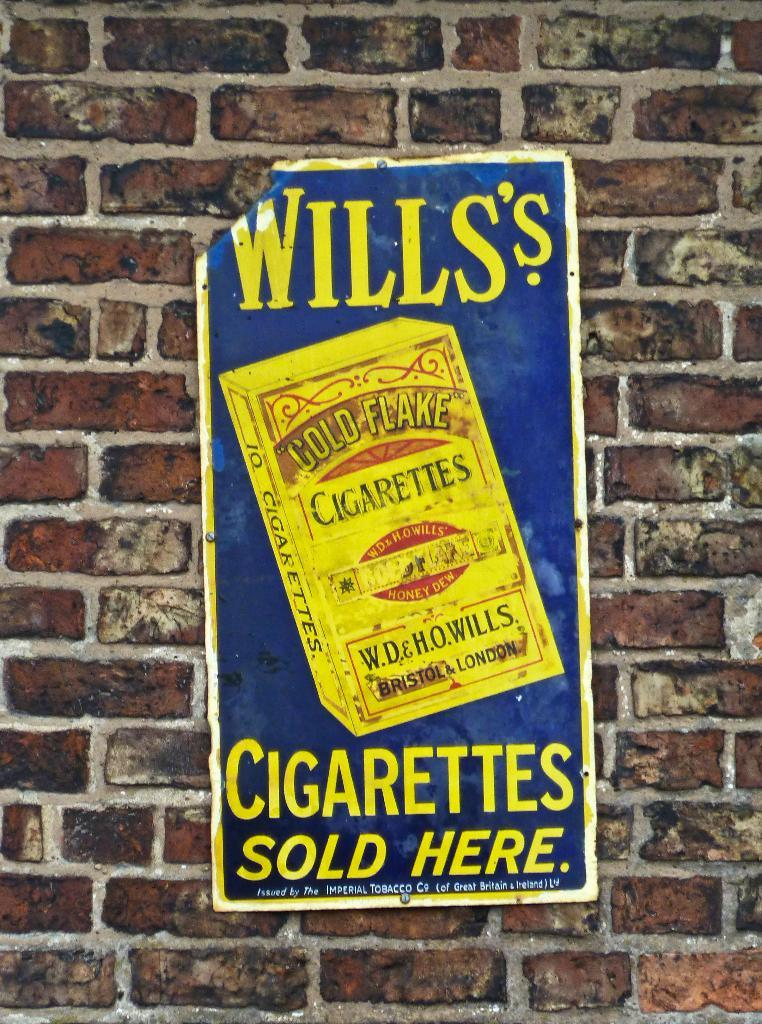<image>
Write a terse but informative summary of the picture. Advertisement poster on a brick wall for Wills's branded cigarettes that contain gold flake. . 